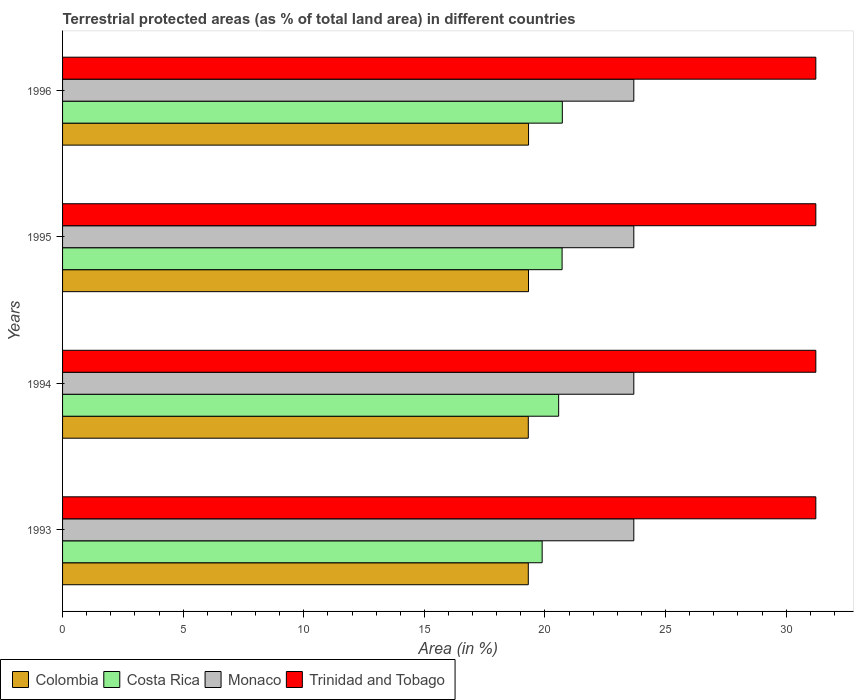How many different coloured bars are there?
Give a very brief answer. 4. Are the number of bars per tick equal to the number of legend labels?
Provide a succinct answer. Yes. How many bars are there on the 2nd tick from the top?
Provide a short and direct response. 4. How many bars are there on the 1st tick from the bottom?
Your answer should be compact. 4. In how many cases, is the number of bars for a given year not equal to the number of legend labels?
Offer a terse response. 0. What is the percentage of terrestrial protected land in Monaco in 1996?
Ensure brevity in your answer.  23.68. Across all years, what is the maximum percentage of terrestrial protected land in Costa Rica?
Offer a very short reply. 20.72. Across all years, what is the minimum percentage of terrestrial protected land in Trinidad and Tobago?
Offer a very short reply. 31.23. In which year was the percentage of terrestrial protected land in Costa Rica maximum?
Your response must be concise. 1996. What is the total percentage of terrestrial protected land in Monaco in the graph?
Offer a terse response. 94.74. What is the difference between the percentage of terrestrial protected land in Trinidad and Tobago in 1994 and that in 1996?
Make the answer very short. 0. What is the difference between the percentage of terrestrial protected land in Monaco in 1994 and the percentage of terrestrial protected land in Trinidad and Tobago in 1993?
Offer a terse response. -7.55. What is the average percentage of terrestrial protected land in Trinidad and Tobago per year?
Make the answer very short. 31.23. In the year 1994, what is the difference between the percentage of terrestrial protected land in Trinidad and Tobago and percentage of terrestrial protected land in Monaco?
Make the answer very short. 7.55. In how many years, is the percentage of terrestrial protected land in Costa Rica greater than 11 %?
Your answer should be very brief. 4. What is the ratio of the percentage of terrestrial protected land in Costa Rica in 1993 to that in 1996?
Your answer should be compact. 0.96. Is the percentage of terrestrial protected land in Monaco in 1995 less than that in 1996?
Offer a terse response. No. Is the difference between the percentage of terrestrial protected land in Trinidad and Tobago in 1995 and 1996 greater than the difference between the percentage of terrestrial protected land in Monaco in 1995 and 1996?
Provide a succinct answer. No. What is the difference between the highest and the lowest percentage of terrestrial protected land in Costa Rica?
Provide a short and direct response. 0.84. In how many years, is the percentage of terrestrial protected land in Costa Rica greater than the average percentage of terrestrial protected land in Costa Rica taken over all years?
Provide a short and direct response. 3. Is the sum of the percentage of terrestrial protected land in Monaco in 1994 and 1995 greater than the maximum percentage of terrestrial protected land in Colombia across all years?
Your answer should be compact. Yes. What does the 1st bar from the bottom in 1996 represents?
Offer a terse response. Colombia. How many bars are there?
Your response must be concise. 16. Are the values on the major ticks of X-axis written in scientific E-notation?
Ensure brevity in your answer.  No. Does the graph contain any zero values?
Keep it short and to the point. No. Does the graph contain grids?
Give a very brief answer. No. Where does the legend appear in the graph?
Your answer should be compact. Bottom left. How many legend labels are there?
Offer a terse response. 4. How are the legend labels stacked?
Keep it short and to the point. Horizontal. What is the title of the graph?
Provide a short and direct response. Terrestrial protected areas (as % of total land area) in different countries. Does "Low income" appear as one of the legend labels in the graph?
Provide a succinct answer. No. What is the label or title of the X-axis?
Your answer should be compact. Area (in %). What is the Area (in %) in Colombia in 1993?
Your response must be concise. 19.31. What is the Area (in %) in Costa Rica in 1993?
Keep it short and to the point. 19.88. What is the Area (in %) of Monaco in 1993?
Your answer should be compact. 23.68. What is the Area (in %) of Trinidad and Tobago in 1993?
Ensure brevity in your answer.  31.23. What is the Area (in %) of Colombia in 1994?
Give a very brief answer. 19.31. What is the Area (in %) in Costa Rica in 1994?
Offer a very short reply. 20.57. What is the Area (in %) in Monaco in 1994?
Give a very brief answer. 23.68. What is the Area (in %) of Trinidad and Tobago in 1994?
Offer a very short reply. 31.23. What is the Area (in %) of Colombia in 1995?
Provide a short and direct response. 19.32. What is the Area (in %) of Costa Rica in 1995?
Offer a terse response. 20.71. What is the Area (in %) of Monaco in 1995?
Keep it short and to the point. 23.68. What is the Area (in %) in Trinidad and Tobago in 1995?
Provide a short and direct response. 31.23. What is the Area (in %) in Colombia in 1996?
Give a very brief answer. 19.32. What is the Area (in %) of Costa Rica in 1996?
Offer a very short reply. 20.72. What is the Area (in %) in Monaco in 1996?
Your answer should be compact. 23.68. What is the Area (in %) of Trinidad and Tobago in 1996?
Provide a succinct answer. 31.23. Across all years, what is the maximum Area (in %) of Colombia?
Make the answer very short. 19.32. Across all years, what is the maximum Area (in %) in Costa Rica?
Give a very brief answer. 20.72. Across all years, what is the maximum Area (in %) in Monaco?
Your answer should be compact. 23.68. Across all years, what is the maximum Area (in %) in Trinidad and Tobago?
Provide a succinct answer. 31.23. Across all years, what is the minimum Area (in %) of Colombia?
Make the answer very short. 19.31. Across all years, what is the minimum Area (in %) of Costa Rica?
Offer a terse response. 19.88. Across all years, what is the minimum Area (in %) of Monaco?
Keep it short and to the point. 23.68. Across all years, what is the minimum Area (in %) of Trinidad and Tobago?
Your answer should be compact. 31.23. What is the total Area (in %) in Colombia in the graph?
Your response must be concise. 77.26. What is the total Area (in %) in Costa Rica in the graph?
Give a very brief answer. 81.88. What is the total Area (in %) in Monaco in the graph?
Ensure brevity in your answer.  94.74. What is the total Area (in %) in Trinidad and Tobago in the graph?
Offer a terse response. 124.92. What is the difference between the Area (in %) in Colombia in 1993 and that in 1994?
Make the answer very short. 0. What is the difference between the Area (in %) in Costa Rica in 1993 and that in 1994?
Provide a short and direct response. -0.68. What is the difference between the Area (in %) in Trinidad and Tobago in 1993 and that in 1994?
Ensure brevity in your answer.  0. What is the difference between the Area (in %) of Colombia in 1993 and that in 1995?
Your answer should be compact. -0.01. What is the difference between the Area (in %) of Costa Rica in 1993 and that in 1995?
Offer a very short reply. -0.83. What is the difference between the Area (in %) of Trinidad and Tobago in 1993 and that in 1995?
Provide a succinct answer. 0. What is the difference between the Area (in %) in Colombia in 1993 and that in 1996?
Your response must be concise. -0.01. What is the difference between the Area (in %) of Costa Rica in 1993 and that in 1996?
Your answer should be compact. -0.84. What is the difference between the Area (in %) of Monaco in 1993 and that in 1996?
Your answer should be compact. 0. What is the difference between the Area (in %) in Colombia in 1994 and that in 1995?
Give a very brief answer. -0.01. What is the difference between the Area (in %) of Costa Rica in 1994 and that in 1995?
Provide a short and direct response. -0.14. What is the difference between the Area (in %) in Monaco in 1994 and that in 1995?
Make the answer very short. 0. What is the difference between the Area (in %) in Colombia in 1994 and that in 1996?
Keep it short and to the point. -0.01. What is the difference between the Area (in %) in Costa Rica in 1994 and that in 1996?
Your response must be concise. -0.15. What is the difference between the Area (in %) of Monaco in 1994 and that in 1996?
Your answer should be very brief. 0. What is the difference between the Area (in %) in Colombia in 1995 and that in 1996?
Provide a succinct answer. -0. What is the difference between the Area (in %) in Costa Rica in 1995 and that in 1996?
Provide a succinct answer. -0.01. What is the difference between the Area (in %) of Trinidad and Tobago in 1995 and that in 1996?
Ensure brevity in your answer.  0. What is the difference between the Area (in %) of Colombia in 1993 and the Area (in %) of Costa Rica in 1994?
Ensure brevity in your answer.  -1.26. What is the difference between the Area (in %) of Colombia in 1993 and the Area (in %) of Monaco in 1994?
Your answer should be very brief. -4.37. What is the difference between the Area (in %) in Colombia in 1993 and the Area (in %) in Trinidad and Tobago in 1994?
Give a very brief answer. -11.92. What is the difference between the Area (in %) of Costa Rica in 1993 and the Area (in %) of Monaco in 1994?
Provide a succinct answer. -3.8. What is the difference between the Area (in %) in Costa Rica in 1993 and the Area (in %) in Trinidad and Tobago in 1994?
Give a very brief answer. -11.35. What is the difference between the Area (in %) of Monaco in 1993 and the Area (in %) of Trinidad and Tobago in 1994?
Make the answer very short. -7.55. What is the difference between the Area (in %) of Colombia in 1993 and the Area (in %) of Costa Rica in 1995?
Offer a very short reply. -1.4. What is the difference between the Area (in %) in Colombia in 1993 and the Area (in %) in Monaco in 1995?
Your answer should be very brief. -4.37. What is the difference between the Area (in %) of Colombia in 1993 and the Area (in %) of Trinidad and Tobago in 1995?
Your answer should be compact. -11.92. What is the difference between the Area (in %) in Costa Rica in 1993 and the Area (in %) in Monaco in 1995?
Keep it short and to the point. -3.8. What is the difference between the Area (in %) of Costa Rica in 1993 and the Area (in %) of Trinidad and Tobago in 1995?
Ensure brevity in your answer.  -11.35. What is the difference between the Area (in %) in Monaco in 1993 and the Area (in %) in Trinidad and Tobago in 1995?
Your response must be concise. -7.55. What is the difference between the Area (in %) in Colombia in 1993 and the Area (in %) in Costa Rica in 1996?
Provide a succinct answer. -1.41. What is the difference between the Area (in %) of Colombia in 1993 and the Area (in %) of Monaco in 1996?
Your answer should be compact. -4.37. What is the difference between the Area (in %) in Colombia in 1993 and the Area (in %) in Trinidad and Tobago in 1996?
Provide a succinct answer. -11.92. What is the difference between the Area (in %) in Costa Rica in 1993 and the Area (in %) in Monaco in 1996?
Your response must be concise. -3.8. What is the difference between the Area (in %) of Costa Rica in 1993 and the Area (in %) of Trinidad and Tobago in 1996?
Provide a succinct answer. -11.35. What is the difference between the Area (in %) in Monaco in 1993 and the Area (in %) in Trinidad and Tobago in 1996?
Offer a terse response. -7.55. What is the difference between the Area (in %) in Colombia in 1994 and the Area (in %) in Costa Rica in 1995?
Keep it short and to the point. -1.4. What is the difference between the Area (in %) of Colombia in 1994 and the Area (in %) of Monaco in 1995?
Keep it short and to the point. -4.37. What is the difference between the Area (in %) in Colombia in 1994 and the Area (in %) in Trinidad and Tobago in 1995?
Offer a terse response. -11.92. What is the difference between the Area (in %) of Costa Rica in 1994 and the Area (in %) of Monaco in 1995?
Ensure brevity in your answer.  -3.12. What is the difference between the Area (in %) in Costa Rica in 1994 and the Area (in %) in Trinidad and Tobago in 1995?
Offer a terse response. -10.66. What is the difference between the Area (in %) of Monaco in 1994 and the Area (in %) of Trinidad and Tobago in 1995?
Provide a succinct answer. -7.55. What is the difference between the Area (in %) in Colombia in 1994 and the Area (in %) in Costa Rica in 1996?
Offer a terse response. -1.41. What is the difference between the Area (in %) in Colombia in 1994 and the Area (in %) in Monaco in 1996?
Ensure brevity in your answer.  -4.37. What is the difference between the Area (in %) in Colombia in 1994 and the Area (in %) in Trinidad and Tobago in 1996?
Your response must be concise. -11.92. What is the difference between the Area (in %) in Costa Rica in 1994 and the Area (in %) in Monaco in 1996?
Offer a terse response. -3.12. What is the difference between the Area (in %) in Costa Rica in 1994 and the Area (in %) in Trinidad and Tobago in 1996?
Offer a very short reply. -10.66. What is the difference between the Area (in %) of Monaco in 1994 and the Area (in %) of Trinidad and Tobago in 1996?
Ensure brevity in your answer.  -7.55. What is the difference between the Area (in %) of Colombia in 1995 and the Area (in %) of Costa Rica in 1996?
Offer a very short reply. -1.4. What is the difference between the Area (in %) of Colombia in 1995 and the Area (in %) of Monaco in 1996?
Provide a succinct answer. -4.37. What is the difference between the Area (in %) in Colombia in 1995 and the Area (in %) in Trinidad and Tobago in 1996?
Your answer should be very brief. -11.91. What is the difference between the Area (in %) in Costa Rica in 1995 and the Area (in %) in Monaco in 1996?
Offer a very short reply. -2.97. What is the difference between the Area (in %) of Costa Rica in 1995 and the Area (in %) of Trinidad and Tobago in 1996?
Your answer should be very brief. -10.52. What is the difference between the Area (in %) of Monaco in 1995 and the Area (in %) of Trinidad and Tobago in 1996?
Provide a short and direct response. -7.55. What is the average Area (in %) of Colombia per year?
Your response must be concise. 19.31. What is the average Area (in %) in Costa Rica per year?
Give a very brief answer. 20.47. What is the average Area (in %) of Monaco per year?
Your response must be concise. 23.68. What is the average Area (in %) in Trinidad and Tobago per year?
Make the answer very short. 31.23. In the year 1993, what is the difference between the Area (in %) of Colombia and Area (in %) of Costa Rica?
Offer a very short reply. -0.57. In the year 1993, what is the difference between the Area (in %) of Colombia and Area (in %) of Monaco?
Your answer should be very brief. -4.37. In the year 1993, what is the difference between the Area (in %) of Colombia and Area (in %) of Trinidad and Tobago?
Ensure brevity in your answer.  -11.92. In the year 1993, what is the difference between the Area (in %) of Costa Rica and Area (in %) of Monaco?
Offer a very short reply. -3.8. In the year 1993, what is the difference between the Area (in %) in Costa Rica and Area (in %) in Trinidad and Tobago?
Your answer should be compact. -11.35. In the year 1993, what is the difference between the Area (in %) of Monaco and Area (in %) of Trinidad and Tobago?
Make the answer very short. -7.55. In the year 1994, what is the difference between the Area (in %) of Colombia and Area (in %) of Costa Rica?
Provide a short and direct response. -1.26. In the year 1994, what is the difference between the Area (in %) in Colombia and Area (in %) in Monaco?
Provide a succinct answer. -4.37. In the year 1994, what is the difference between the Area (in %) of Colombia and Area (in %) of Trinidad and Tobago?
Your response must be concise. -11.92. In the year 1994, what is the difference between the Area (in %) of Costa Rica and Area (in %) of Monaco?
Make the answer very short. -3.12. In the year 1994, what is the difference between the Area (in %) in Costa Rica and Area (in %) in Trinidad and Tobago?
Your answer should be compact. -10.66. In the year 1994, what is the difference between the Area (in %) in Monaco and Area (in %) in Trinidad and Tobago?
Keep it short and to the point. -7.55. In the year 1995, what is the difference between the Area (in %) of Colombia and Area (in %) of Costa Rica?
Make the answer very short. -1.39. In the year 1995, what is the difference between the Area (in %) of Colombia and Area (in %) of Monaco?
Offer a terse response. -4.37. In the year 1995, what is the difference between the Area (in %) in Colombia and Area (in %) in Trinidad and Tobago?
Make the answer very short. -11.91. In the year 1995, what is the difference between the Area (in %) of Costa Rica and Area (in %) of Monaco?
Keep it short and to the point. -2.97. In the year 1995, what is the difference between the Area (in %) of Costa Rica and Area (in %) of Trinidad and Tobago?
Provide a succinct answer. -10.52. In the year 1995, what is the difference between the Area (in %) in Monaco and Area (in %) in Trinidad and Tobago?
Make the answer very short. -7.55. In the year 1996, what is the difference between the Area (in %) of Colombia and Area (in %) of Costa Rica?
Give a very brief answer. -1.4. In the year 1996, what is the difference between the Area (in %) of Colombia and Area (in %) of Monaco?
Offer a terse response. -4.36. In the year 1996, what is the difference between the Area (in %) of Colombia and Area (in %) of Trinidad and Tobago?
Your answer should be compact. -11.91. In the year 1996, what is the difference between the Area (in %) of Costa Rica and Area (in %) of Monaco?
Provide a succinct answer. -2.96. In the year 1996, what is the difference between the Area (in %) in Costa Rica and Area (in %) in Trinidad and Tobago?
Your answer should be compact. -10.51. In the year 1996, what is the difference between the Area (in %) in Monaco and Area (in %) in Trinidad and Tobago?
Provide a succinct answer. -7.55. What is the ratio of the Area (in %) of Colombia in 1993 to that in 1994?
Make the answer very short. 1. What is the ratio of the Area (in %) of Costa Rica in 1993 to that in 1994?
Your answer should be compact. 0.97. What is the ratio of the Area (in %) of Trinidad and Tobago in 1993 to that in 1994?
Make the answer very short. 1. What is the ratio of the Area (in %) in Costa Rica in 1993 to that in 1995?
Provide a short and direct response. 0.96. What is the ratio of the Area (in %) of Monaco in 1993 to that in 1995?
Your answer should be very brief. 1. What is the ratio of the Area (in %) of Costa Rica in 1993 to that in 1996?
Ensure brevity in your answer.  0.96. What is the ratio of the Area (in %) in Monaco in 1993 to that in 1996?
Your response must be concise. 1. What is the ratio of the Area (in %) of Trinidad and Tobago in 1994 to that in 1995?
Offer a terse response. 1. What is the ratio of the Area (in %) of Costa Rica in 1994 to that in 1996?
Give a very brief answer. 0.99. What is the ratio of the Area (in %) of Colombia in 1995 to that in 1996?
Make the answer very short. 1. What is the ratio of the Area (in %) in Trinidad and Tobago in 1995 to that in 1996?
Offer a very short reply. 1. What is the difference between the highest and the second highest Area (in %) in Colombia?
Ensure brevity in your answer.  0. What is the difference between the highest and the second highest Area (in %) of Costa Rica?
Offer a very short reply. 0.01. What is the difference between the highest and the second highest Area (in %) of Monaco?
Offer a terse response. 0. What is the difference between the highest and the second highest Area (in %) of Trinidad and Tobago?
Your response must be concise. 0. What is the difference between the highest and the lowest Area (in %) of Colombia?
Make the answer very short. 0.01. What is the difference between the highest and the lowest Area (in %) in Costa Rica?
Your answer should be compact. 0.84. What is the difference between the highest and the lowest Area (in %) of Monaco?
Offer a terse response. 0. 